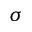Convert formula to latex. <formula><loc_0><loc_0><loc_500><loc_500>\sigma</formula> 